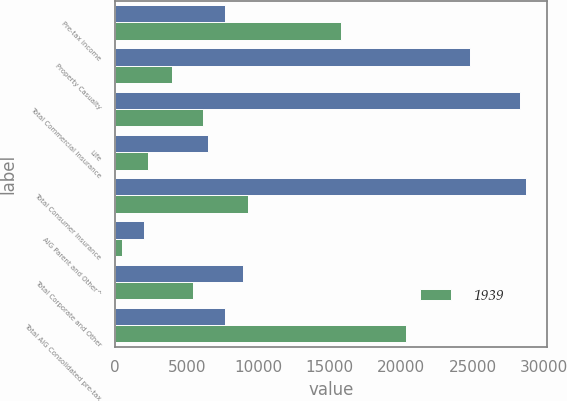Convert chart. <chart><loc_0><loc_0><loc_500><loc_500><stacked_bar_chart><ecel><fcel>Pre-tax income<fcel>Property Casualty<fcel>Total Commercial Insurance<fcel>Life<fcel>Total Consumer Insurance<fcel>AIG Parent and Other^<fcel>Total Corporate and Other<fcel>Total AIG Consolidated pre-tax<nl><fcel>nan<fcel>7696.5<fcel>24799<fcel>28286<fcel>6457<fcel>28746<fcel>2028<fcel>8936<fcel>7696.5<nl><fcel>1939<fcel>15810<fcel>3951<fcel>6163<fcel>2283<fcel>9262<fcel>459<fcel>5416<fcel>20306<nl></chart> 